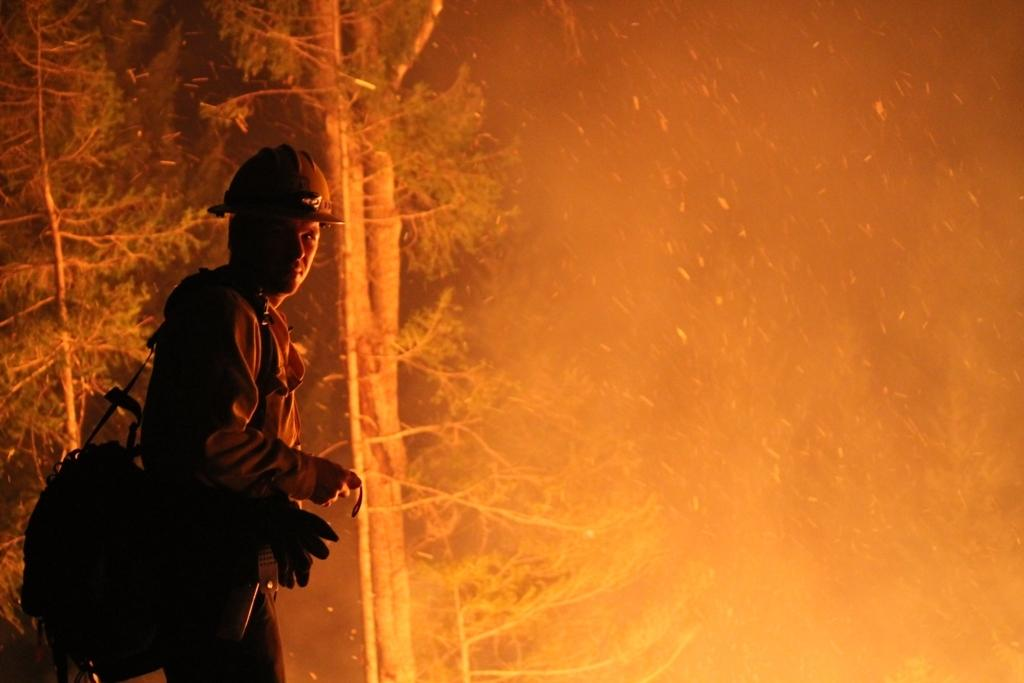Who or what is present in the image? There is a person in the image. What is the person wearing? The person is wearing a bag. What can be seen in the background of the image? There are trees and smoke visible in the background of the image. Can you see any tickets in the person's hand in the image? There is no mention of tickets in the image, so we cannot determine if the person is holding any. 